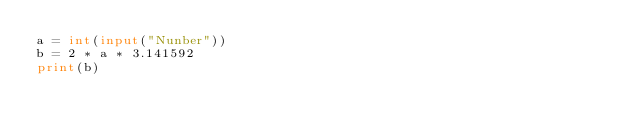Convert code to text. <code><loc_0><loc_0><loc_500><loc_500><_Python_>a = int(input("Nunber"))
b = 2 * a * 3.141592
print(b)</code> 